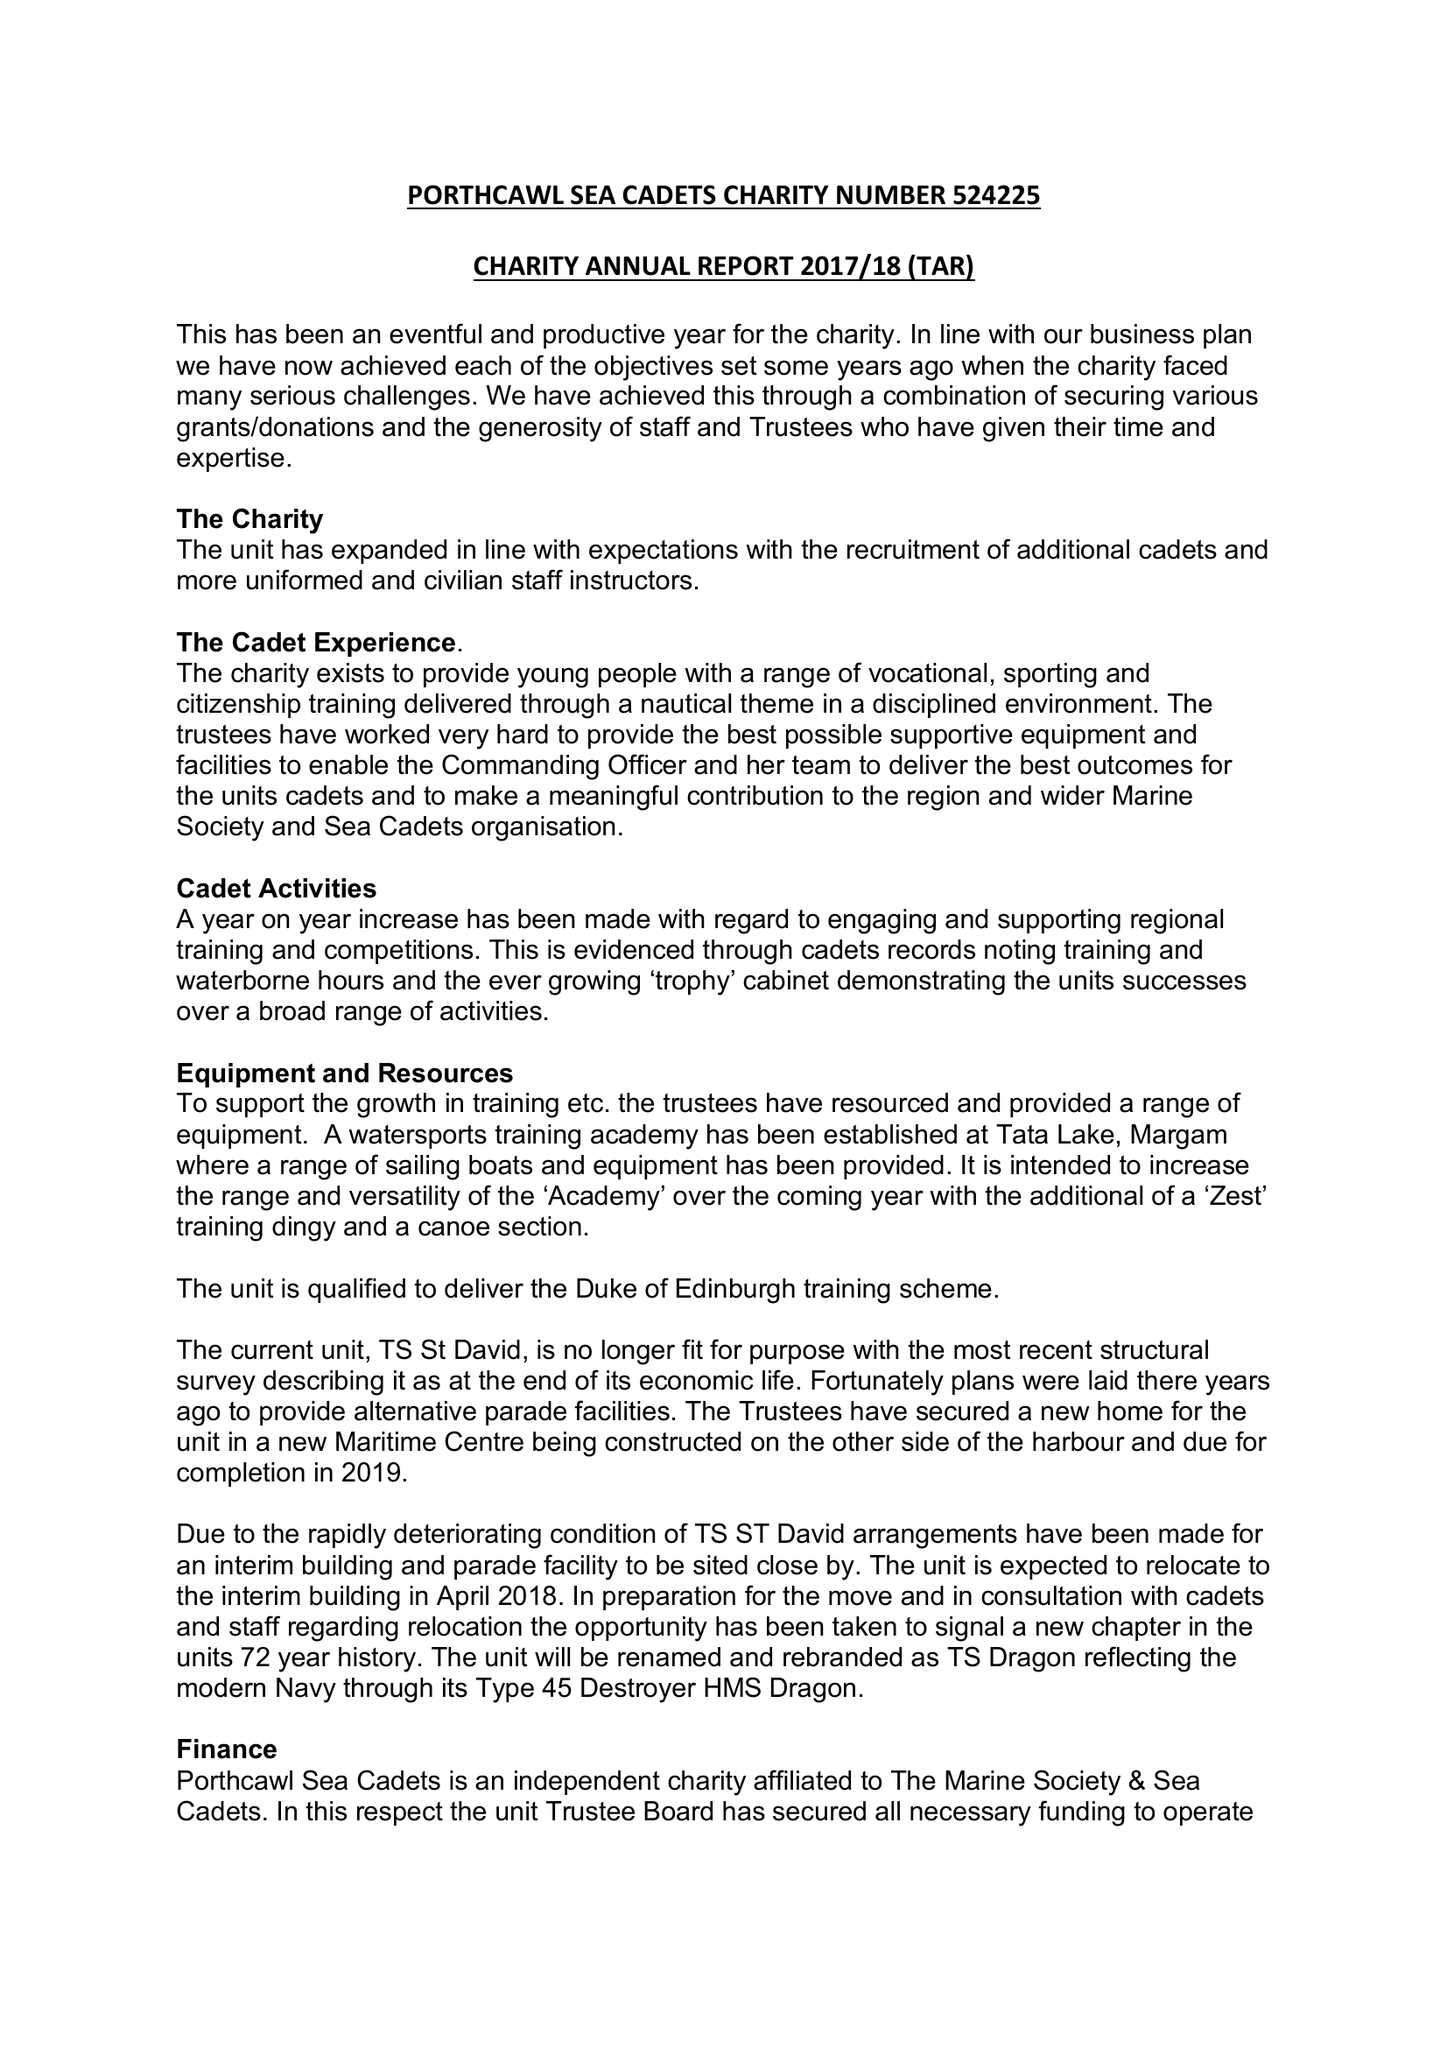What is the value for the address__post_town?
Answer the question using a single word or phrase. PORTHCAWL 